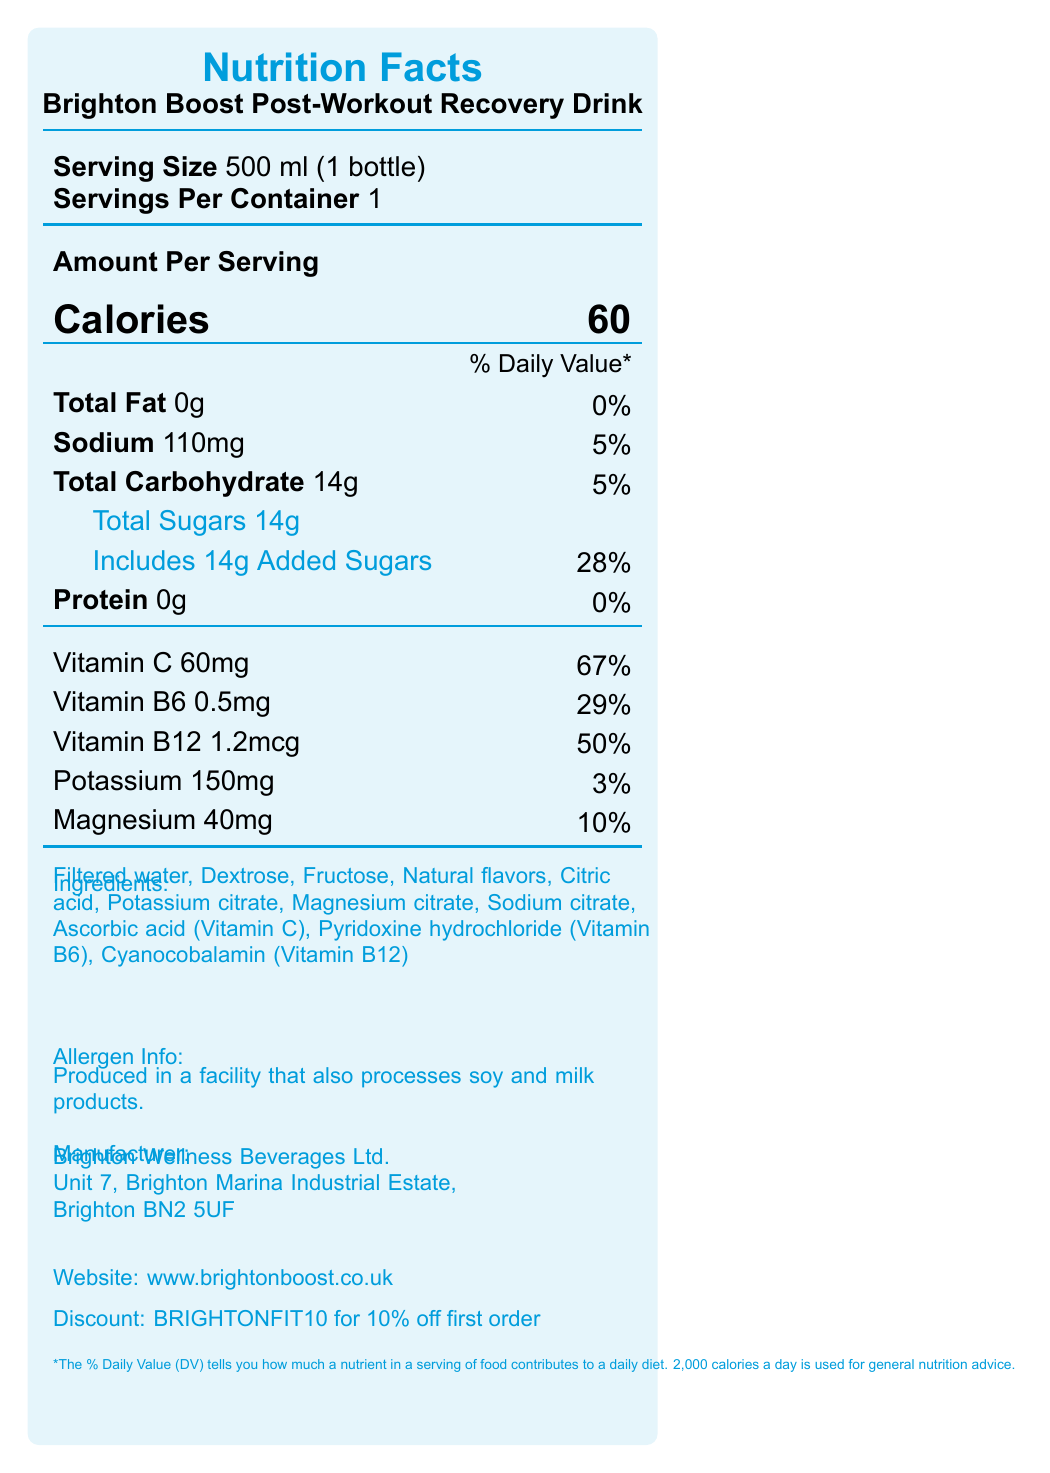what is the name of the product? The product name is prominently displayed at the top of the document.
Answer: Brighton Boost Post-Workout Recovery Drink how many calories are in one serving? The document states that each serving contains 60 calories.
Answer: 60 what is the serving size of the drink? The serving size listed is 500 ml, equivalent to one bottle.
Answer: 500 ml (1 bottle) how much vitamin C is in one serving and what percentage of the daily value does it represent? The document states that one serving contains 60mg of vitamin C, which is 67% of the daily value.
Answer: 60mg, 67% what is the sodium content per serving? The sodium content per serving is indicated as 110mg.
Answer: 110mg what is the total carbohydrate content in the drink? A. 12g B. 14g C. 16g D. 18g The document shows that the total carbohydrate content per serving is 14g.
Answer: B which of the following ingredients is NOT listed for the drink? A. Dextrose B. High Fructose Corn Syrup C. Natural flavors D. Citric Acid High Fructose Corn Syrup is not listed among the ingredients provided.
Answer: B does the drink contain any protein? The document lists the protein content as 0g, indicating that the drink does not contain any protein.
Answer: No is this drink suitable for people with soy allergies? The document mentions it is produced in a facility that also processes soy, meaning cross-contamination is possible.
Answer: No what are the benefits of consuming this drink? The document lists these benefits in detail.
Answer: Low-calorie formula, replenishes electrolytes, supports muscle recovery, boosts immune system with Vitamin C, ideal for busy lifestyles is there a discount code available for first-time buyers? The document provides a discount code: BRIGHTONFIT10 for 10% off the first online order.
Answer: Yes where is the manufacturer of the drink located? The document lists the manufacturer's address as Unit 7, Brighton Marina Industrial Estate, Brighton BN2 5UF.
Answer: Brighton Marina Industrial Estate, Brighton BN2 5UF what material is the bottle made from? The eco-friendly section of the document states that the bottle is made from 100% recycled plastic.
Answer: 100% recycled plastic how should the drink be stored after opening? The shelf life section advises to refrigerate after opening and consume within 3 days.
Answer: Refrigerate and consume within 3 days what is the overall daily value percentage of added sugars in the drink? The document states that added sugars account for 28% of the daily value.
Answer: 28% what temperature is the drink best served at? The ideal temperature section indicates that the drink is best served chilled at 3-5°C.
Answer: 3-5°C what supporting nutrients are included in the drink? These nutrients are listed in the nutritional information section.
Answer: Vitamin C, Vitamin B6, Vitamin B12, Potassium, Magnesium does the drink provide any fat per serving? The document states the total fat as 0g.
Answer: No which vitamin has the highest daily value percentage in the drink? Vitamin C has the highest daily value percentage at 67%.
Answer: Vitamin C how long is the shelf life of the drink when unopened? The shelf life when unopened is indicated to be 12 months.
Answer: 12 months what ingredients are used to provide the natural flavors in the drink? The document lists "Natural flavors" but does not specify the source of these flavors.
Answer: Cannot be determined summarize the main features of the Brighton Boost Post-Workout Recovery Drink. The summary encapsulates the key aspects of the product including nutritional content, benefits, eco-friendly design, manufacturer information, and serving recommendations.
Answer: This is a 500 ml, 60 calorie post-workout drink designed for recovery with essential vitamins and electrolytes like Vitamin C, B6, B12, Potassium, and Magnesium. It boasts benefits such as a low-calorie count, muscle recovery support, and immune boosting. The drink is eco-friendly, with a bottle made from recycled plastic and a biodegradable label. The product is manufactured by Brighton Wellness Beverages Ltd., and is best served chilled. 